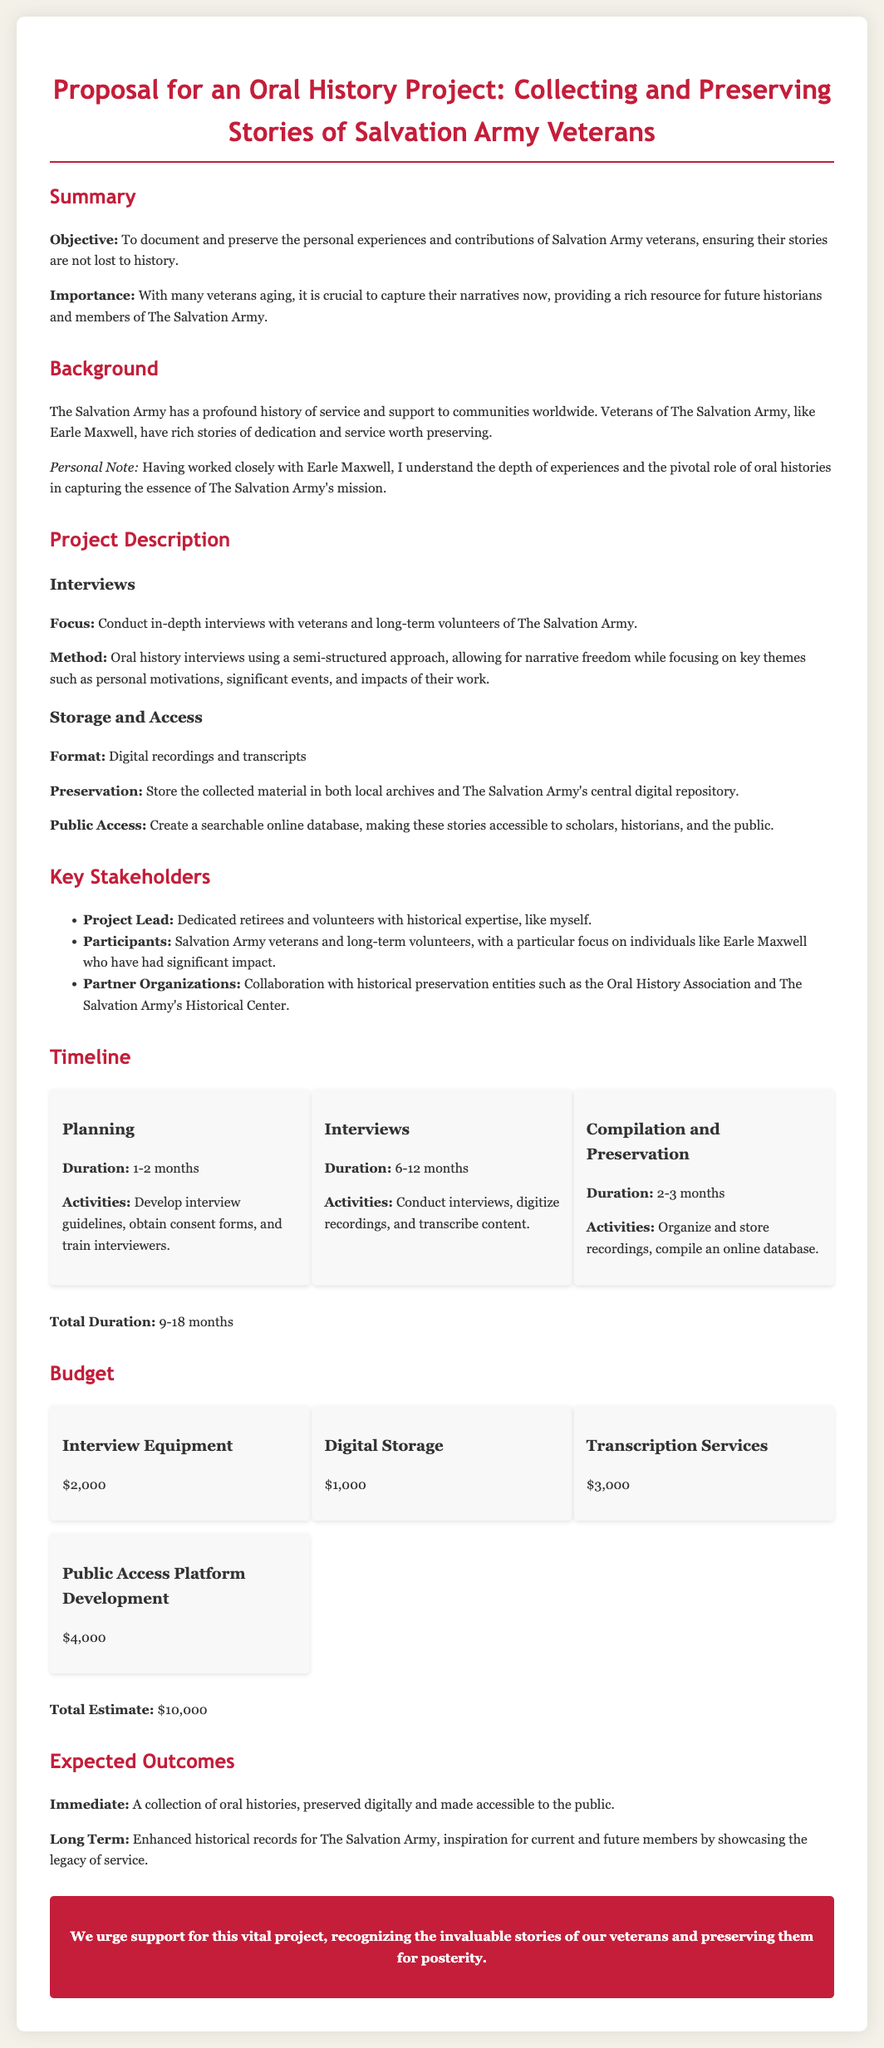What is the objective of the project? The objective is to document and preserve the personal experiences and contributions of Salvation Army veterans.
Answer: To document and preserve the personal experiences and contributions of Salvation Army veterans What is the estimated total budget? The total budget is the sum of all budget items listed in the proposal.
Answer: $10,000 How long is the interview phase planned to last? The interview phase is designated a specific duration within the timeline section of the document.
Answer: 6-12 months Who is mentioned as a significant participant in the project? The document specifically names a prominent veteran associated with The Salvation Army.
Answer: Earle Maxwell What type of materials will be collected and preserved? The project focuses on specific mediums for preserving the collected stories, as indicated in the document.
Answer: Digital recordings and transcripts What is the total duration of the project? The document provides a range for the overall timing of the entire project, from planning to completion.
Answer: 9-18 months Who are the key stakeholders identified in the proposal? The document outlines individuals and groups involved in the project, indicating their roles and significance.
Answer: Project Lead, Participants, Partner Organizations What is the purpose of creating a searchable online database? The document states the desired outcome of public access and information sharing related to the project.
Answer: To make these stories accessible to scholars, historians, and the public What kind of approach will be used for the interviews? The document specifies the methodology of conducting interviews within the project description.
Answer: Semi-structured approach 